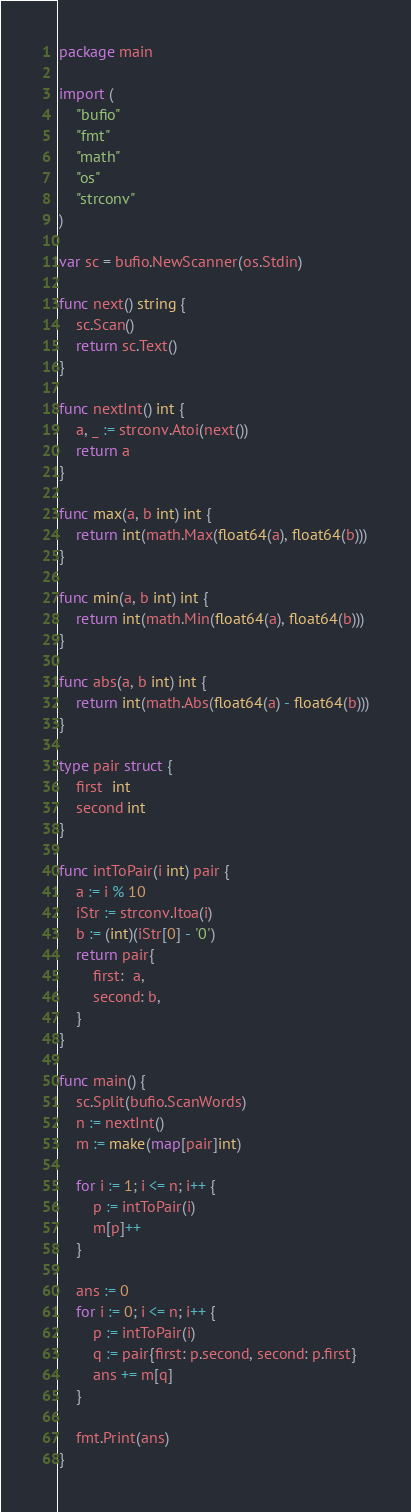<code> <loc_0><loc_0><loc_500><loc_500><_Go_>package main

import (
	"bufio"
	"fmt"
	"math"
	"os"
	"strconv"
)

var sc = bufio.NewScanner(os.Stdin)

func next() string {
	sc.Scan()
	return sc.Text()
}

func nextInt() int {
	a, _ := strconv.Atoi(next())
	return a
}

func max(a, b int) int {
	return int(math.Max(float64(a), float64(b)))
}

func min(a, b int) int {
	return int(math.Min(float64(a), float64(b)))
}

func abs(a, b int) int {
	return int(math.Abs(float64(a) - float64(b)))
}

type pair struct {
	first  int
	second int
}

func intToPair(i int) pair {
	a := i % 10
	iStr := strconv.Itoa(i)
	b := (int)(iStr[0] - '0')
	return pair{
		first:  a,
		second: b,
	}
}

func main() {
	sc.Split(bufio.ScanWords)
	n := nextInt()
	m := make(map[pair]int)

	for i := 1; i <= n; i++ {
		p := intToPair(i)
		m[p]++
	}

	ans := 0
	for i := 0; i <= n; i++ {
		p := intToPair(i)
		q := pair{first: p.second, second: p.first}
		ans += m[q]
	}

	fmt.Print(ans)
}
</code> 